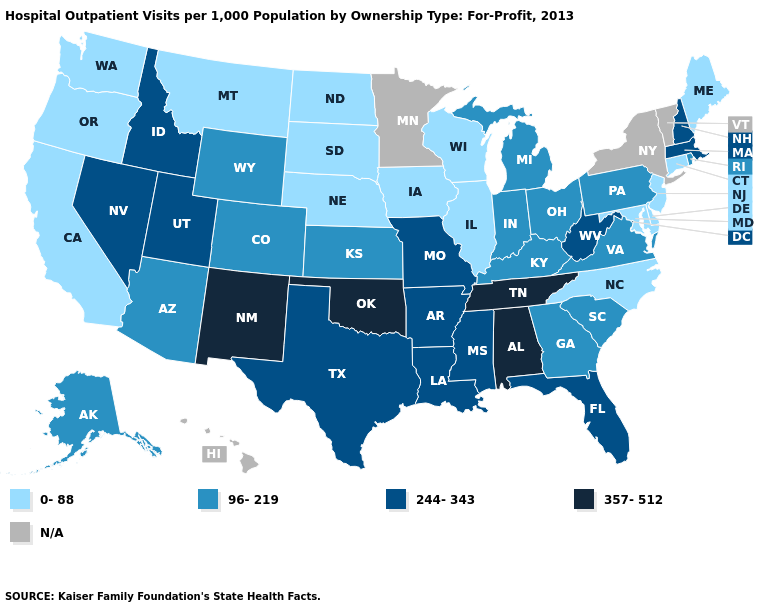Which states have the lowest value in the USA?
Give a very brief answer. California, Connecticut, Delaware, Illinois, Iowa, Maine, Maryland, Montana, Nebraska, New Jersey, North Carolina, North Dakota, Oregon, South Dakota, Washington, Wisconsin. Which states hav the highest value in the MidWest?
Quick response, please. Missouri. What is the value of Oregon?
Quick response, please. 0-88. What is the highest value in states that border Mississippi?
Be succinct. 357-512. Name the states that have a value in the range 244-343?
Answer briefly. Arkansas, Florida, Idaho, Louisiana, Massachusetts, Mississippi, Missouri, Nevada, New Hampshire, Texas, Utah, West Virginia. Among the states that border Michigan , does Indiana have the highest value?
Answer briefly. Yes. What is the value of Arkansas?
Write a very short answer. 244-343. Among the states that border Colorado , which have the highest value?
Concise answer only. New Mexico, Oklahoma. Does North Carolina have the lowest value in the South?
Concise answer only. Yes. Among the states that border Nevada , does Idaho have the lowest value?
Keep it brief. No. What is the lowest value in the USA?
Concise answer only. 0-88. Among the states that border Kentucky , does Virginia have the highest value?
Write a very short answer. No. Name the states that have a value in the range 244-343?
Be succinct. Arkansas, Florida, Idaho, Louisiana, Massachusetts, Mississippi, Missouri, Nevada, New Hampshire, Texas, Utah, West Virginia. What is the value of Florida?
Answer briefly. 244-343. What is the value of Texas?
Concise answer only. 244-343. 